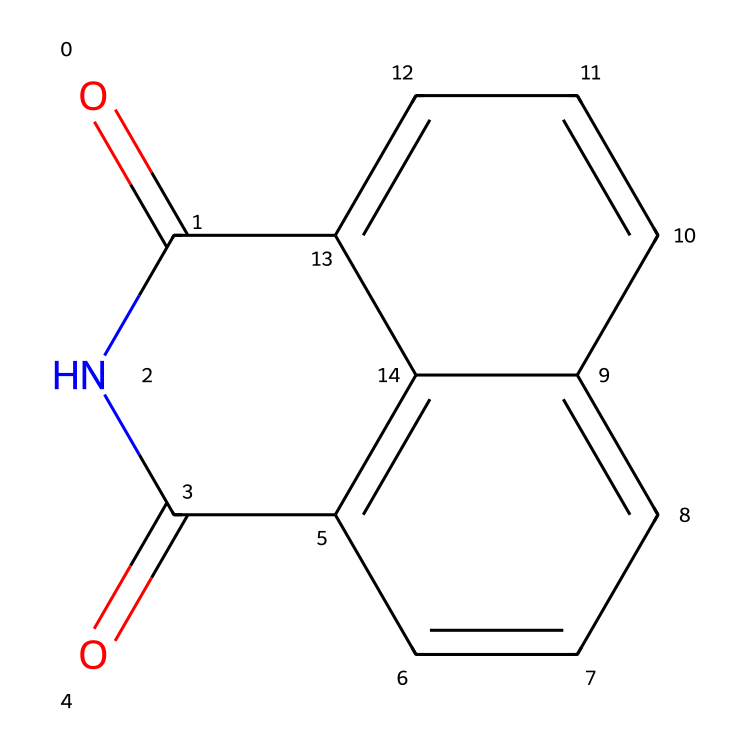What is the molecular formula of naphthalimide? To determine the molecular formula, we can break down the structure by counting each type of atom. The SMILES representation indicates there are 10 carbon atoms, 6 hydrogen atoms, 2 nitrogen atoms, and 2 oxygen atoms. Thus, the molecular formula is C10H6N2O2.
Answer: C10H6N2O2 How many rings are present in the naphthalimide structure? Examining the structure, we see that it consists of fused aromatic rings. There are two rings present, as indicated by the two distinct sets of conjugated carbons.
Answer: 2 What type of functional groups are present in naphthalimide? The structure includes carbonyl (C=O) groups and a nitrogen atom within a ring, indicating it has imide functional groups. The presence of two carbonyls adjacent to nitrogen signals that it is indeed an imide.
Answer: imide What is the total number of nitrogen atoms in naphthalimide? Upon reviewing the structure, we identify 2 distinct nitrogen atoms present in the ring structure.
Answer: 2 Which part of the molecule contributes to its fluorescent properties? The extended pi-conjugated system formed by the fused aromatic rings and the carbonyl groups allows for efficient energy absorption and emission, which is characteristic of fluorescent compounds. This structural arrangement enhances the electron delocalization necessary for fluorescence.
Answer: conjugated system 